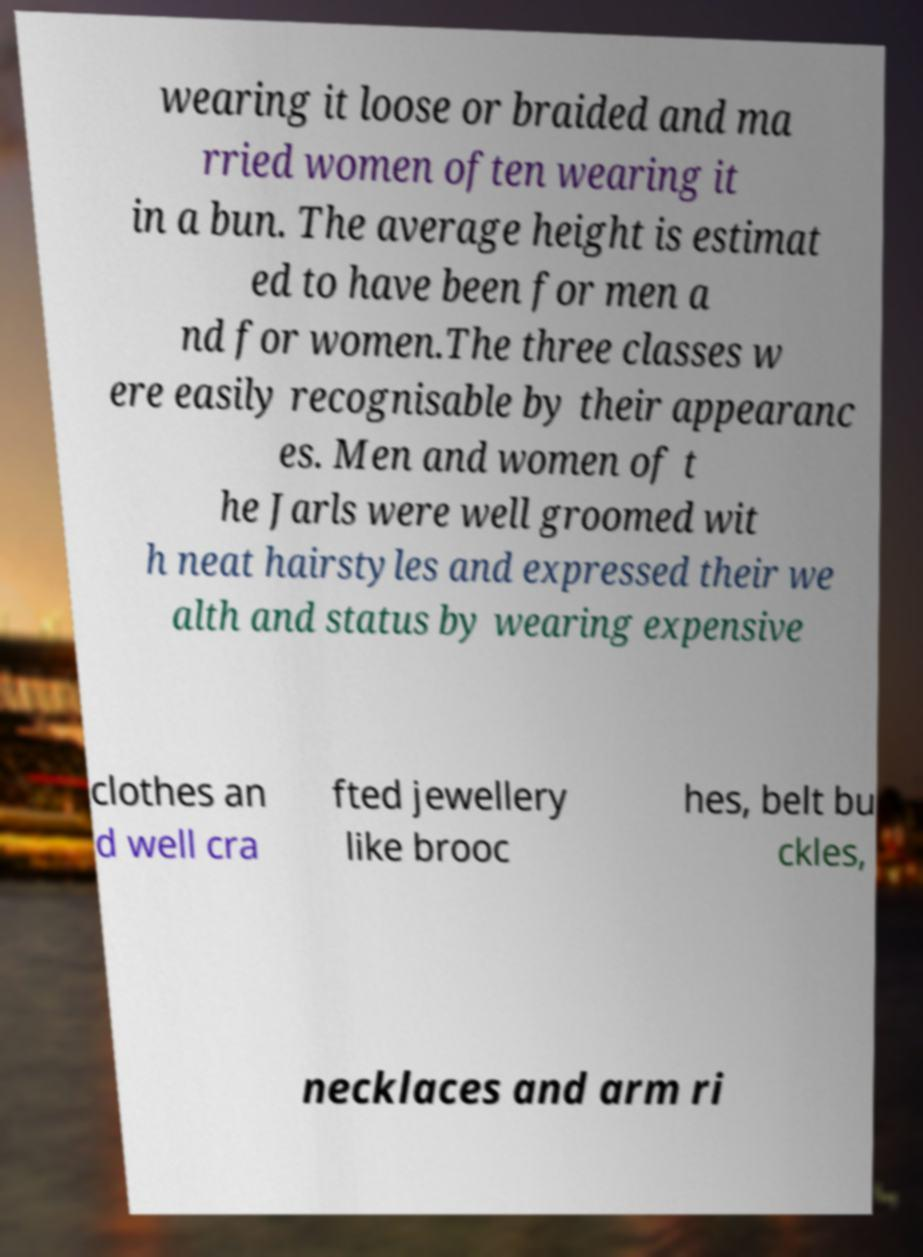Can you accurately transcribe the text from the provided image for me? wearing it loose or braided and ma rried women often wearing it in a bun. The average height is estimat ed to have been for men a nd for women.The three classes w ere easily recognisable by their appearanc es. Men and women of t he Jarls were well groomed wit h neat hairstyles and expressed their we alth and status by wearing expensive clothes an d well cra fted jewellery like brooc hes, belt bu ckles, necklaces and arm ri 